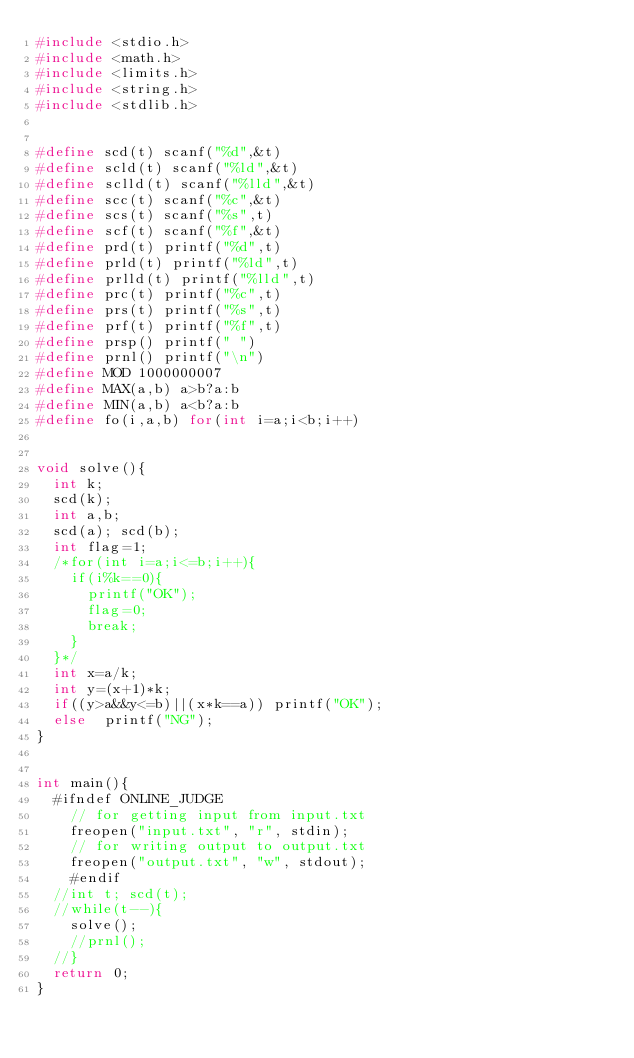Convert code to text. <code><loc_0><loc_0><loc_500><loc_500><_C_>#include <stdio.h>
#include <math.h>
#include <limits.h>
#include <string.h>
#include <stdlib.h>


#define scd(t) scanf("%d",&t)
#define scld(t) scanf("%ld",&t)
#define sclld(t) scanf("%lld",&t)
#define scc(t) scanf("%c",&t)
#define scs(t) scanf("%s",t)
#define scf(t) scanf("%f",&t)
#define prd(t) printf("%d",t)
#define prld(t) printf("%ld",t)
#define prlld(t) printf("%lld",t)
#define prc(t) printf("%c",t)
#define prs(t) printf("%s",t)
#define prf(t) printf("%f",t)
#define prsp() printf(" ")
#define prnl() printf("\n")
#define MOD 1000000007
#define MAX(a,b) a>b?a:b
#define MIN(a,b) a<b?a:b
#define fo(i,a,b) for(int i=a;i<b;i++)


void solve(){
	int k;
	scd(k);
	int a,b;
	scd(a); scd(b);
	int flag=1;
	/*for(int i=a;i<=b;i++){
		if(i%k==0){
			printf("OK");
			flag=0;
			break;
		}
	}*/
	int x=a/k;
	int y=(x+1)*k;
	if((y>a&&y<=b)||(x*k==a)) printf("OK");
	else  printf("NG");
}


int main(){
	#ifndef ONLINE_JUDGE
    // for getting input from input.txt
    freopen("input.txt", "r", stdin);
    // for writing output to output.txt
    freopen("output.txt", "w", stdout);
    #endif
	//int t; scd(t);
	//while(t--){
		solve();
		//prnl();
	//}
	return 0;
}</code> 